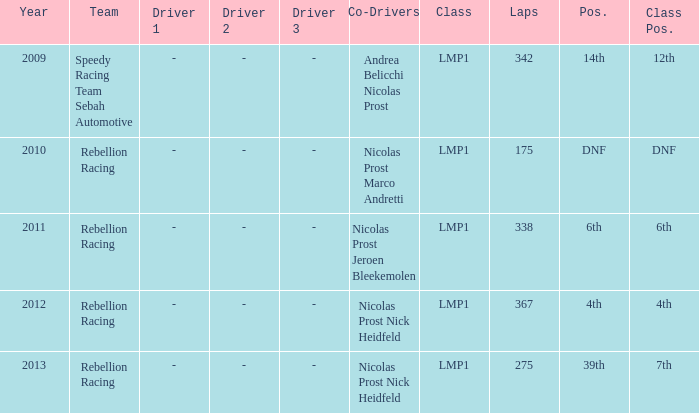What was the class position of the team that was in the 4th position? 4th. 